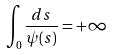Convert formula to latex. <formula><loc_0><loc_0><loc_500><loc_500>\int _ { 0 } \frac { d s } { \psi ( s ) } = + \infty</formula> 